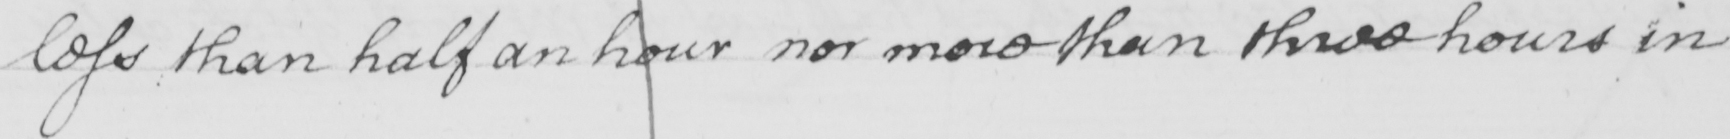What text is written in this handwritten line? less than half an hour nor more than three hours in 